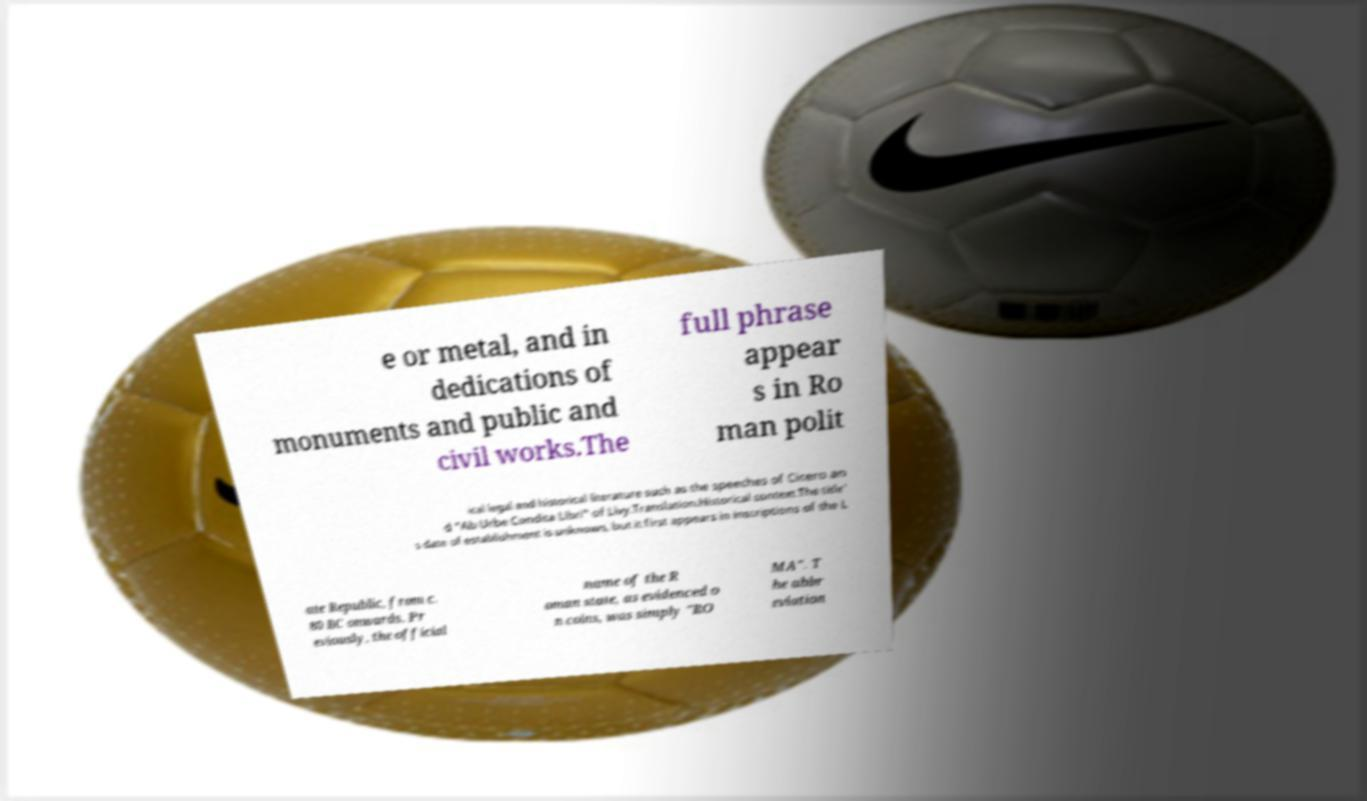Can you read and provide the text displayed in the image?This photo seems to have some interesting text. Can you extract and type it out for me? e or metal, and in dedications of monuments and public and civil works.The full phrase appear s in Ro man polit ical legal and historical literature such as the speeches of Cicero an d "Ab Urbe Condita Libri" of Livy.Translation.Historical context.The title' s date of establishment is unknown, but it first appears in inscriptions of the L ate Republic, from c. 80 BC onwards. Pr eviously, the official name of the R oman state, as evidenced o n coins, was simply "RO MA". T he abbr eviation 